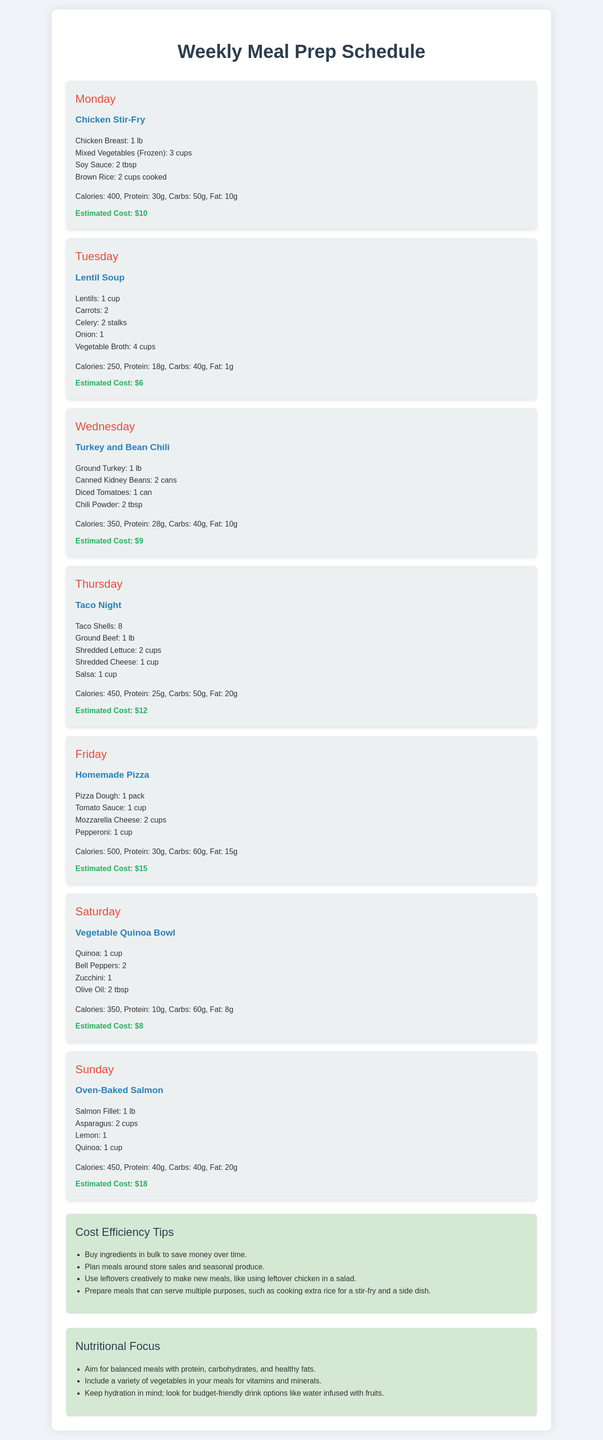What is the meal for Monday? The document lists the meal for Monday as "Chicken Stir-Fry."
Answer: Chicken Stir-Fry How much does the Tuesday meal cost? The estimated cost for the Tuesday meal, Lentil Soup, is provided in the document as $6.
Answer: $6 What is the protein content of the Thursday meal? The nutritional value section for Taco Night on Thursday indicates 25g of protein.
Answer: 25g Which meal has the highest estimated cost? Comparing the costs listed, the meal with the highest estimated cost is Oven-Baked Salmon at $18.
Answer: $18 How many cups of mixed vegetables are used for the Monday meal? The ingredients list for Chicken Stir-Fry mentions using 3 cups of mixed vegetables.
Answer: 3 cups What additional tips are given for cost efficiency? The document suggests multiple tips, one of which is to "Buy ingredients in bulk to save money over time."
Answer: Buy ingredients in bulk What is the total caloric value of the Homemade Pizza? The nutritional value section states that Homemade Pizza has a total of 500 calories.
Answer: 500 calories Which day has a meal containing quinoa? The Vegetable Quinoa Bowl on Saturday and the Oven-Baked Salmon on Sunday both include quinoa.
Answer: Saturday and Sunday What kind of protein is used in the Wednesday meal? The Wednesday meal, Turkey and Bean Chili, includes Ground Turkey as its protein source.
Answer: Ground Turkey 